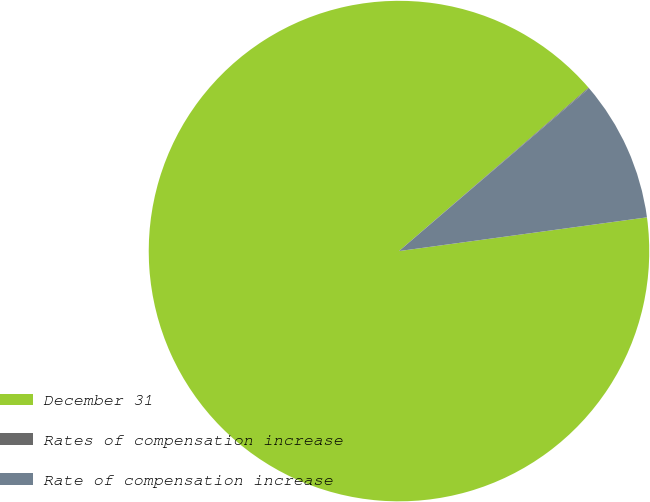<chart> <loc_0><loc_0><loc_500><loc_500><pie_chart><fcel>December 31<fcel>Rates of compensation increase<fcel>Rate of compensation increase<nl><fcel>90.83%<fcel>0.05%<fcel>9.12%<nl></chart> 